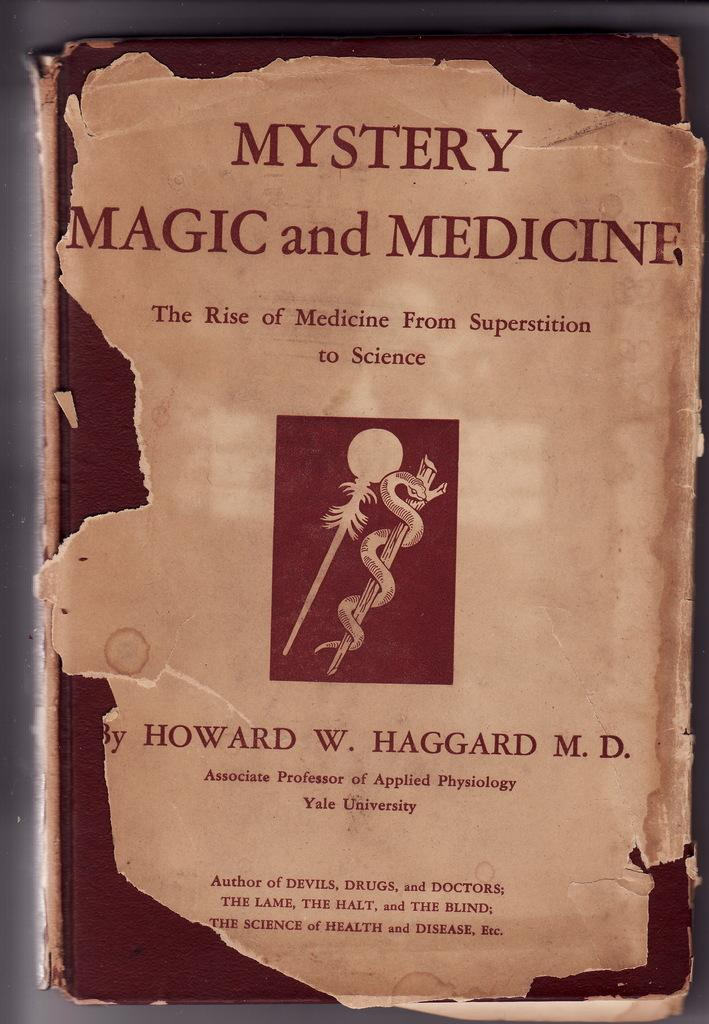What is the main subject of the image? The main subject of the image is a book. How is the book positioned in the image? The image shows a top view of the book. Can you see any text or information on the book? Yes, there is some information visible on the book. What type of oatmeal is being prepared in the image? There is no oatmeal or any indication of food preparation in the image; it shows a book from a top view. What time of day is it in the image? The time of day cannot be determined from the image, as it only shows a book from a top view. 